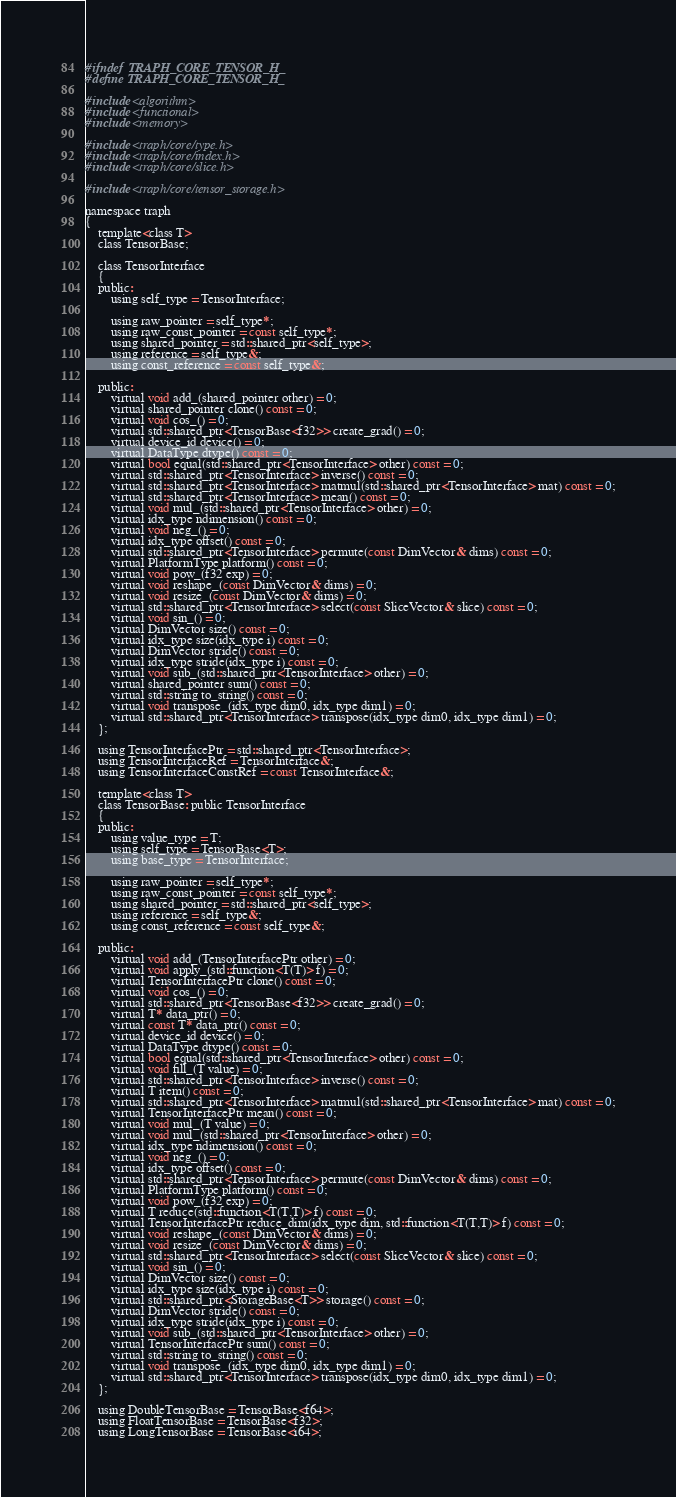<code> <loc_0><loc_0><loc_500><loc_500><_C_>#ifndef TRAPH_CORE_TENSOR_H_
#define TRAPH_CORE_TENSOR_H_

#include <algorithm>
#include <functional>
#include <memory>

#include <traph/core/type.h>
#include <traph/core/index.h>
#include <traph/core/slice.h>

#include <traph/core/tensor_storage.h>

namespace traph
{
	template<class T>
	class TensorBase;

    class TensorInterface
    {
    public:
        using self_type = TensorInterface;

        using raw_pointer = self_type*;
        using raw_const_pointer = const self_type*;
        using shared_pointer = std::shared_ptr<self_type>;
        using reference = self_type&;
        using const_reference = const self_type&;

    public:
        virtual void add_(shared_pointer other) = 0;
        virtual shared_pointer clone() const = 0;
        virtual void cos_() = 0;
        virtual std::shared_ptr<TensorBase<f32>> create_grad() = 0;
        virtual device_id device() = 0;
        virtual DataType dtype() const = 0;
        virtual bool equal(std::shared_ptr<TensorInterface> other) const = 0;
        virtual std::shared_ptr<TensorInterface> inverse() const = 0;
        virtual std::shared_ptr<TensorInterface> matmul(std::shared_ptr<TensorInterface> mat) const = 0;
        virtual std::shared_ptr<TensorInterface> mean() const = 0;
        virtual void mul_(std::shared_ptr<TensorInterface> other) = 0;
        virtual idx_type ndimension() const = 0;
        virtual void neg_() = 0;
        virtual idx_type offset() const = 0;
        virtual std::shared_ptr<TensorInterface> permute(const DimVector& dims) const = 0;
        virtual PlatformType platform() const = 0;
        virtual void pow_(f32 exp) = 0;
        virtual void reshape_(const DimVector& dims) = 0;
        virtual void resize_(const DimVector& dims) = 0;
        virtual std::shared_ptr<TensorInterface> select(const SliceVector& slice) const = 0;
        virtual void sin_() = 0;
		virtual DimVector size() const = 0;
		virtual idx_type size(idx_type i) const = 0;
		virtual DimVector stride() const = 0;
		virtual idx_type stride(idx_type i) const = 0;
        virtual void sub_(std::shared_ptr<TensorInterface> other) = 0;
        virtual shared_pointer sum() const = 0;
        virtual std::string to_string() const = 0;
        virtual void transpose_(idx_type dim0, idx_type dim1) = 0;
        virtual std::shared_ptr<TensorInterface> transpose(idx_type dim0, idx_type dim1) = 0;
    };

    using TensorInterfacePtr = std::shared_ptr<TensorInterface>;
    using TensorInterfaceRef = TensorInterface&;
    using TensorInterfaceConstRef = const TensorInterface&;

    template<class T>
    class TensorBase: public TensorInterface
    {
    public:
        using value_type = T;
        using self_type = TensorBase<T>;
        using base_type = TensorInterface;

        using raw_pointer = self_type*;
        using raw_const_pointer = const self_type*;
        using shared_pointer = std::shared_ptr<self_type>;
        using reference = self_type&;
        using const_reference = const self_type&;
        
    public:
        virtual void add_(TensorInterfacePtr other) = 0;
        virtual void apply_(std::function<T(T)> f) = 0;
        virtual TensorInterfacePtr clone() const = 0;
        virtual void cos_() = 0;
        virtual std::shared_ptr<TensorBase<f32>> create_grad() = 0;
        virtual T* data_ptr() = 0;
        virtual const T* data_ptr() const = 0;
        virtual device_id device() = 0;
        virtual DataType dtype() const = 0;
        virtual bool equal(std::shared_ptr<TensorInterface> other) const = 0;
        virtual void fill_(T value) = 0;
        virtual std::shared_ptr<TensorInterface> inverse() const = 0;
        virtual T item() const = 0;
        virtual std::shared_ptr<TensorInterface> matmul(std::shared_ptr<TensorInterface> mat) const = 0;
        virtual TensorInterfacePtr mean() const = 0;
        virtual void mul_(T value) = 0;
        virtual void mul_(std::shared_ptr<TensorInterface> other) = 0;
        virtual idx_type ndimension() const = 0;
        virtual void neg_() = 0;
        virtual idx_type offset() const = 0;
        virtual std::shared_ptr<TensorInterface> permute(const DimVector& dims) const = 0;
        virtual PlatformType platform() const = 0;
        virtual void pow_(f32 exp) = 0;
        virtual T reduce(std::function<T(T,T)> f) const = 0;
        virtual TensorInterfacePtr reduce_dim(idx_type dim, std::function<T(T,T)> f) const = 0;
        virtual void reshape_(const DimVector& dims) = 0;
        virtual void resize_(const DimVector& dims) = 0;
        virtual std::shared_ptr<TensorInterface> select(const SliceVector& slice) const = 0;
        virtual void sin_() = 0;
		virtual DimVector size() const = 0;
		virtual idx_type size(idx_type i) const = 0;
        virtual std::shared_ptr<StorageBase<T>> storage() const = 0;
		virtual DimVector stride() const = 0;
		virtual idx_type stride(idx_type i) const = 0;
        virtual void sub_(std::shared_ptr<TensorInterface> other) = 0;
        virtual TensorInterfacePtr sum() const = 0;
        virtual std::string to_string() const = 0;
        virtual void transpose_(idx_type dim0, idx_type dim1) = 0;
        virtual std::shared_ptr<TensorInterface> transpose(idx_type dim0, idx_type dim1) = 0;
    };

    using DoubleTensorBase = TensorBase<f64>;
    using FloatTensorBase = TensorBase<f32>;
    using LongTensorBase = TensorBase<i64>;</code> 